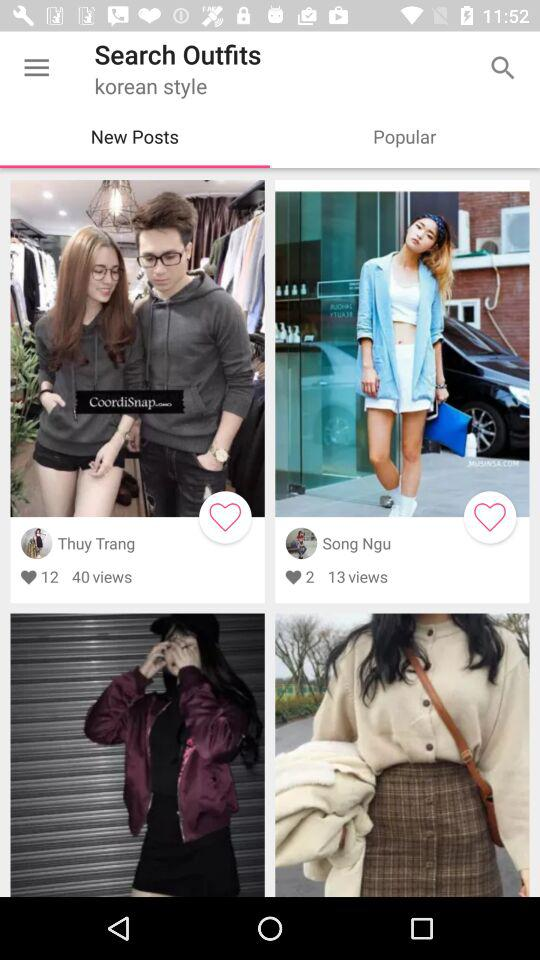For what style is the person searching for outfits? The style is Korean. 